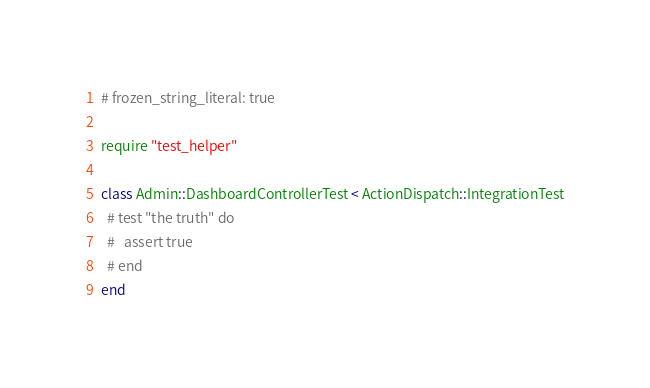<code> <loc_0><loc_0><loc_500><loc_500><_Ruby_># frozen_string_literal: true

require "test_helper"

class Admin::DashboardControllerTest < ActionDispatch::IntegrationTest
  # test "the truth" do
  #   assert true
  # end
end
</code> 